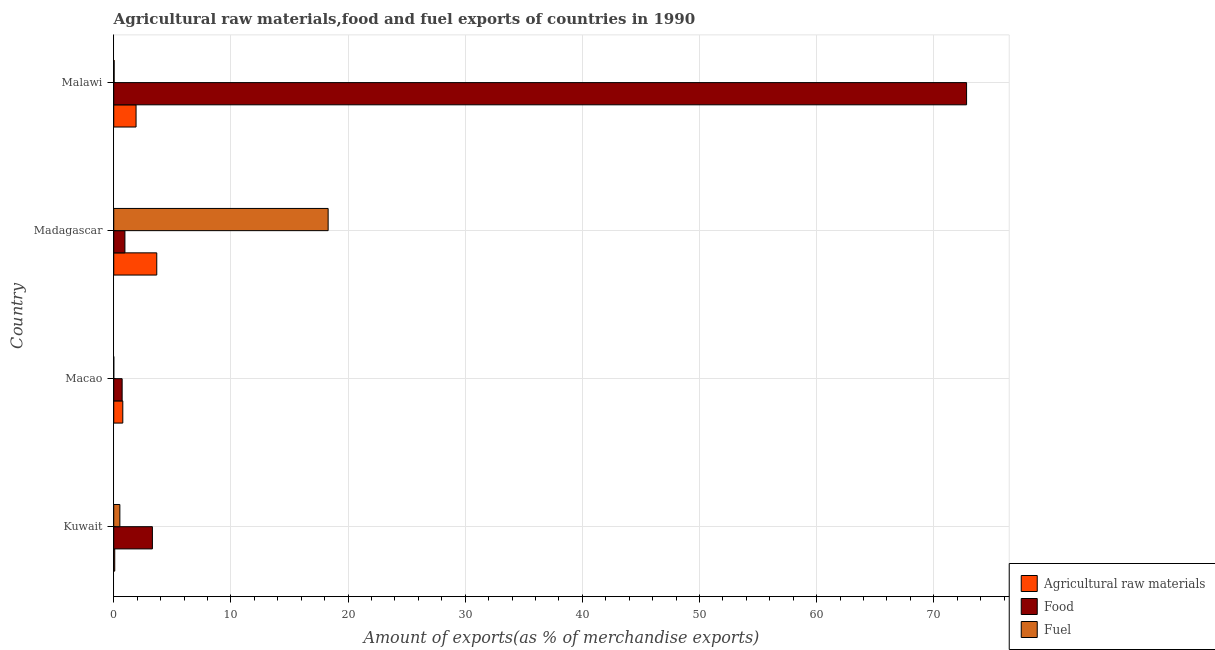How many groups of bars are there?
Provide a short and direct response. 4. Are the number of bars per tick equal to the number of legend labels?
Your answer should be compact. Yes. How many bars are there on the 1st tick from the top?
Offer a very short reply. 3. What is the label of the 1st group of bars from the top?
Offer a terse response. Malawi. What is the percentage of fuel exports in Malawi?
Offer a terse response. 0.03. Across all countries, what is the maximum percentage of food exports?
Your answer should be very brief. 72.8. Across all countries, what is the minimum percentage of fuel exports?
Make the answer very short. 0. In which country was the percentage of raw materials exports maximum?
Your answer should be compact. Madagascar. In which country was the percentage of fuel exports minimum?
Give a very brief answer. Macao. What is the total percentage of food exports in the graph?
Ensure brevity in your answer.  77.77. What is the difference between the percentage of raw materials exports in Kuwait and that in Malawi?
Keep it short and to the point. -1.82. What is the difference between the percentage of fuel exports in Macao and the percentage of food exports in Malawi?
Keep it short and to the point. -72.8. What is the average percentage of food exports per country?
Your answer should be compact. 19.44. What is the difference between the percentage of fuel exports and percentage of raw materials exports in Malawi?
Provide a short and direct response. -1.87. What is the ratio of the percentage of raw materials exports in Macao to that in Madagascar?
Offer a terse response. 0.21. What is the difference between the highest and the second highest percentage of raw materials exports?
Provide a short and direct response. 1.77. What is the difference between the highest and the lowest percentage of raw materials exports?
Your answer should be very brief. 3.59. In how many countries, is the percentage of food exports greater than the average percentage of food exports taken over all countries?
Offer a very short reply. 1. Is the sum of the percentage of food exports in Madagascar and Malawi greater than the maximum percentage of raw materials exports across all countries?
Ensure brevity in your answer.  Yes. What does the 3rd bar from the top in Malawi represents?
Provide a succinct answer. Agricultural raw materials. What does the 2nd bar from the bottom in Kuwait represents?
Offer a terse response. Food. How many bars are there?
Ensure brevity in your answer.  12. Are the values on the major ticks of X-axis written in scientific E-notation?
Provide a succinct answer. No. Does the graph contain grids?
Ensure brevity in your answer.  Yes. What is the title of the graph?
Provide a succinct answer. Agricultural raw materials,food and fuel exports of countries in 1990. Does "Social insurance" appear as one of the legend labels in the graph?
Give a very brief answer. No. What is the label or title of the X-axis?
Keep it short and to the point. Amount of exports(as % of merchandise exports). What is the label or title of the Y-axis?
Provide a succinct answer. Country. What is the Amount of exports(as % of merchandise exports) of Agricultural raw materials in Kuwait?
Your response must be concise. 0.08. What is the Amount of exports(as % of merchandise exports) of Food in Kuwait?
Offer a very short reply. 3.3. What is the Amount of exports(as % of merchandise exports) in Fuel in Kuwait?
Offer a terse response. 0.52. What is the Amount of exports(as % of merchandise exports) of Agricultural raw materials in Macao?
Your answer should be compact. 0.77. What is the Amount of exports(as % of merchandise exports) in Food in Macao?
Your answer should be compact. 0.72. What is the Amount of exports(as % of merchandise exports) in Fuel in Macao?
Give a very brief answer. 0. What is the Amount of exports(as % of merchandise exports) in Agricultural raw materials in Madagascar?
Provide a short and direct response. 3.67. What is the Amount of exports(as % of merchandise exports) in Food in Madagascar?
Provide a succinct answer. 0.95. What is the Amount of exports(as % of merchandise exports) in Fuel in Madagascar?
Give a very brief answer. 18.3. What is the Amount of exports(as % of merchandise exports) of Agricultural raw materials in Malawi?
Offer a terse response. 1.91. What is the Amount of exports(as % of merchandise exports) in Food in Malawi?
Offer a very short reply. 72.8. What is the Amount of exports(as % of merchandise exports) in Fuel in Malawi?
Your response must be concise. 0.03. Across all countries, what is the maximum Amount of exports(as % of merchandise exports) in Agricultural raw materials?
Your answer should be compact. 3.67. Across all countries, what is the maximum Amount of exports(as % of merchandise exports) of Food?
Provide a succinct answer. 72.8. Across all countries, what is the maximum Amount of exports(as % of merchandise exports) in Fuel?
Keep it short and to the point. 18.3. Across all countries, what is the minimum Amount of exports(as % of merchandise exports) in Agricultural raw materials?
Your response must be concise. 0.08. Across all countries, what is the minimum Amount of exports(as % of merchandise exports) in Food?
Give a very brief answer. 0.72. Across all countries, what is the minimum Amount of exports(as % of merchandise exports) of Fuel?
Offer a very short reply. 0. What is the total Amount of exports(as % of merchandise exports) in Agricultural raw materials in the graph?
Your answer should be compact. 6.44. What is the total Amount of exports(as % of merchandise exports) in Food in the graph?
Make the answer very short. 77.77. What is the total Amount of exports(as % of merchandise exports) in Fuel in the graph?
Offer a very short reply. 18.86. What is the difference between the Amount of exports(as % of merchandise exports) of Agricultural raw materials in Kuwait and that in Macao?
Keep it short and to the point. -0.69. What is the difference between the Amount of exports(as % of merchandise exports) in Food in Kuwait and that in Macao?
Offer a very short reply. 2.58. What is the difference between the Amount of exports(as % of merchandise exports) of Fuel in Kuwait and that in Macao?
Ensure brevity in your answer.  0.52. What is the difference between the Amount of exports(as % of merchandise exports) of Agricultural raw materials in Kuwait and that in Madagascar?
Offer a very short reply. -3.59. What is the difference between the Amount of exports(as % of merchandise exports) of Food in Kuwait and that in Madagascar?
Provide a succinct answer. 2.35. What is the difference between the Amount of exports(as % of merchandise exports) in Fuel in Kuwait and that in Madagascar?
Ensure brevity in your answer.  -17.78. What is the difference between the Amount of exports(as % of merchandise exports) in Agricultural raw materials in Kuwait and that in Malawi?
Ensure brevity in your answer.  -1.82. What is the difference between the Amount of exports(as % of merchandise exports) of Food in Kuwait and that in Malawi?
Provide a short and direct response. -69.5. What is the difference between the Amount of exports(as % of merchandise exports) of Fuel in Kuwait and that in Malawi?
Keep it short and to the point. 0.49. What is the difference between the Amount of exports(as % of merchandise exports) in Agricultural raw materials in Macao and that in Madagascar?
Ensure brevity in your answer.  -2.9. What is the difference between the Amount of exports(as % of merchandise exports) of Food in Macao and that in Madagascar?
Give a very brief answer. -0.24. What is the difference between the Amount of exports(as % of merchandise exports) of Fuel in Macao and that in Madagascar?
Your response must be concise. -18.3. What is the difference between the Amount of exports(as % of merchandise exports) in Agricultural raw materials in Macao and that in Malawi?
Give a very brief answer. -1.13. What is the difference between the Amount of exports(as % of merchandise exports) of Food in Macao and that in Malawi?
Offer a very short reply. -72.08. What is the difference between the Amount of exports(as % of merchandise exports) of Fuel in Macao and that in Malawi?
Give a very brief answer. -0.03. What is the difference between the Amount of exports(as % of merchandise exports) in Agricultural raw materials in Madagascar and that in Malawi?
Offer a very short reply. 1.77. What is the difference between the Amount of exports(as % of merchandise exports) in Food in Madagascar and that in Malawi?
Ensure brevity in your answer.  -71.85. What is the difference between the Amount of exports(as % of merchandise exports) of Fuel in Madagascar and that in Malawi?
Your answer should be compact. 18.27. What is the difference between the Amount of exports(as % of merchandise exports) of Agricultural raw materials in Kuwait and the Amount of exports(as % of merchandise exports) of Food in Macao?
Keep it short and to the point. -0.63. What is the difference between the Amount of exports(as % of merchandise exports) of Agricultural raw materials in Kuwait and the Amount of exports(as % of merchandise exports) of Fuel in Macao?
Your answer should be very brief. 0.08. What is the difference between the Amount of exports(as % of merchandise exports) of Food in Kuwait and the Amount of exports(as % of merchandise exports) of Fuel in Macao?
Keep it short and to the point. 3.3. What is the difference between the Amount of exports(as % of merchandise exports) of Agricultural raw materials in Kuwait and the Amount of exports(as % of merchandise exports) of Food in Madagascar?
Provide a short and direct response. -0.87. What is the difference between the Amount of exports(as % of merchandise exports) of Agricultural raw materials in Kuwait and the Amount of exports(as % of merchandise exports) of Fuel in Madagascar?
Offer a terse response. -18.22. What is the difference between the Amount of exports(as % of merchandise exports) of Food in Kuwait and the Amount of exports(as % of merchandise exports) of Fuel in Madagascar?
Make the answer very short. -15. What is the difference between the Amount of exports(as % of merchandise exports) in Agricultural raw materials in Kuwait and the Amount of exports(as % of merchandise exports) in Food in Malawi?
Provide a succinct answer. -72.72. What is the difference between the Amount of exports(as % of merchandise exports) in Agricultural raw materials in Kuwait and the Amount of exports(as % of merchandise exports) in Fuel in Malawi?
Your response must be concise. 0.05. What is the difference between the Amount of exports(as % of merchandise exports) of Food in Kuwait and the Amount of exports(as % of merchandise exports) of Fuel in Malawi?
Keep it short and to the point. 3.27. What is the difference between the Amount of exports(as % of merchandise exports) in Agricultural raw materials in Macao and the Amount of exports(as % of merchandise exports) in Food in Madagascar?
Your answer should be very brief. -0.18. What is the difference between the Amount of exports(as % of merchandise exports) in Agricultural raw materials in Macao and the Amount of exports(as % of merchandise exports) in Fuel in Madagascar?
Offer a terse response. -17.53. What is the difference between the Amount of exports(as % of merchandise exports) in Food in Macao and the Amount of exports(as % of merchandise exports) in Fuel in Madagascar?
Your answer should be compact. -17.58. What is the difference between the Amount of exports(as % of merchandise exports) of Agricultural raw materials in Macao and the Amount of exports(as % of merchandise exports) of Food in Malawi?
Make the answer very short. -72.03. What is the difference between the Amount of exports(as % of merchandise exports) in Agricultural raw materials in Macao and the Amount of exports(as % of merchandise exports) in Fuel in Malawi?
Your answer should be compact. 0.74. What is the difference between the Amount of exports(as % of merchandise exports) of Food in Macao and the Amount of exports(as % of merchandise exports) of Fuel in Malawi?
Your answer should be very brief. 0.68. What is the difference between the Amount of exports(as % of merchandise exports) in Agricultural raw materials in Madagascar and the Amount of exports(as % of merchandise exports) in Food in Malawi?
Your answer should be very brief. -69.13. What is the difference between the Amount of exports(as % of merchandise exports) of Agricultural raw materials in Madagascar and the Amount of exports(as % of merchandise exports) of Fuel in Malawi?
Ensure brevity in your answer.  3.64. What is the difference between the Amount of exports(as % of merchandise exports) in Food in Madagascar and the Amount of exports(as % of merchandise exports) in Fuel in Malawi?
Ensure brevity in your answer.  0.92. What is the average Amount of exports(as % of merchandise exports) of Agricultural raw materials per country?
Give a very brief answer. 1.61. What is the average Amount of exports(as % of merchandise exports) in Food per country?
Provide a short and direct response. 19.44. What is the average Amount of exports(as % of merchandise exports) in Fuel per country?
Your response must be concise. 4.72. What is the difference between the Amount of exports(as % of merchandise exports) in Agricultural raw materials and Amount of exports(as % of merchandise exports) in Food in Kuwait?
Ensure brevity in your answer.  -3.22. What is the difference between the Amount of exports(as % of merchandise exports) of Agricultural raw materials and Amount of exports(as % of merchandise exports) of Fuel in Kuwait?
Give a very brief answer. -0.44. What is the difference between the Amount of exports(as % of merchandise exports) in Food and Amount of exports(as % of merchandise exports) in Fuel in Kuwait?
Offer a very short reply. 2.78. What is the difference between the Amount of exports(as % of merchandise exports) of Agricultural raw materials and Amount of exports(as % of merchandise exports) of Food in Macao?
Offer a very short reply. 0.06. What is the difference between the Amount of exports(as % of merchandise exports) in Agricultural raw materials and Amount of exports(as % of merchandise exports) in Fuel in Macao?
Ensure brevity in your answer.  0.77. What is the difference between the Amount of exports(as % of merchandise exports) of Food and Amount of exports(as % of merchandise exports) of Fuel in Macao?
Provide a succinct answer. 0.71. What is the difference between the Amount of exports(as % of merchandise exports) of Agricultural raw materials and Amount of exports(as % of merchandise exports) of Food in Madagascar?
Provide a short and direct response. 2.72. What is the difference between the Amount of exports(as % of merchandise exports) in Agricultural raw materials and Amount of exports(as % of merchandise exports) in Fuel in Madagascar?
Your response must be concise. -14.63. What is the difference between the Amount of exports(as % of merchandise exports) in Food and Amount of exports(as % of merchandise exports) in Fuel in Madagascar?
Provide a short and direct response. -17.35. What is the difference between the Amount of exports(as % of merchandise exports) in Agricultural raw materials and Amount of exports(as % of merchandise exports) in Food in Malawi?
Your answer should be very brief. -70.9. What is the difference between the Amount of exports(as % of merchandise exports) in Agricultural raw materials and Amount of exports(as % of merchandise exports) in Fuel in Malawi?
Make the answer very short. 1.87. What is the difference between the Amount of exports(as % of merchandise exports) in Food and Amount of exports(as % of merchandise exports) in Fuel in Malawi?
Your answer should be compact. 72.77. What is the ratio of the Amount of exports(as % of merchandise exports) in Agricultural raw materials in Kuwait to that in Macao?
Your response must be concise. 0.11. What is the ratio of the Amount of exports(as % of merchandise exports) of Food in Kuwait to that in Macao?
Give a very brief answer. 4.6. What is the ratio of the Amount of exports(as % of merchandise exports) in Fuel in Kuwait to that in Macao?
Provide a short and direct response. 198.37. What is the ratio of the Amount of exports(as % of merchandise exports) in Agricultural raw materials in Kuwait to that in Madagascar?
Your answer should be compact. 0.02. What is the ratio of the Amount of exports(as % of merchandise exports) in Food in Kuwait to that in Madagascar?
Your answer should be compact. 3.46. What is the ratio of the Amount of exports(as % of merchandise exports) of Fuel in Kuwait to that in Madagascar?
Your answer should be very brief. 0.03. What is the ratio of the Amount of exports(as % of merchandise exports) of Agricultural raw materials in Kuwait to that in Malawi?
Provide a succinct answer. 0.04. What is the ratio of the Amount of exports(as % of merchandise exports) of Food in Kuwait to that in Malawi?
Your answer should be compact. 0.05. What is the ratio of the Amount of exports(as % of merchandise exports) in Fuel in Kuwait to that in Malawi?
Provide a short and direct response. 15.15. What is the ratio of the Amount of exports(as % of merchandise exports) in Agricultural raw materials in Macao to that in Madagascar?
Provide a succinct answer. 0.21. What is the ratio of the Amount of exports(as % of merchandise exports) of Food in Macao to that in Madagascar?
Offer a terse response. 0.75. What is the ratio of the Amount of exports(as % of merchandise exports) of Fuel in Macao to that in Madagascar?
Keep it short and to the point. 0. What is the ratio of the Amount of exports(as % of merchandise exports) in Agricultural raw materials in Macao to that in Malawi?
Provide a succinct answer. 0.41. What is the ratio of the Amount of exports(as % of merchandise exports) of Food in Macao to that in Malawi?
Give a very brief answer. 0.01. What is the ratio of the Amount of exports(as % of merchandise exports) in Fuel in Macao to that in Malawi?
Provide a short and direct response. 0.08. What is the ratio of the Amount of exports(as % of merchandise exports) in Agricultural raw materials in Madagascar to that in Malawi?
Keep it short and to the point. 1.93. What is the ratio of the Amount of exports(as % of merchandise exports) in Food in Madagascar to that in Malawi?
Your answer should be compact. 0.01. What is the ratio of the Amount of exports(as % of merchandise exports) in Fuel in Madagascar to that in Malawi?
Your answer should be compact. 530.29. What is the difference between the highest and the second highest Amount of exports(as % of merchandise exports) of Agricultural raw materials?
Your response must be concise. 1.77. What is the difference between the highest and the second highest Amount of exports(as % of merchandise exports) of Food?
Your response must be concise. 69.5. What is the difference between the highest and the second highest Amount of exports(as % of merchandise exports) of Fuel?
Your answer should be compact. 17.78. What is the difference between the highest and the lowest Amount of exports(as % of merchandise exports) in Agricultural raw materials?
Make the answer very short. 3.59. What is the difference between the highest and the lowest Amount of exports(as % of merchandise exports) of Food?
Offer a very short reply. 72.08. What is the difference between the highest and the lowest Amount of exports(as % of merchandise exports) in Fuel?
Offer a very short reply. 18.3. 